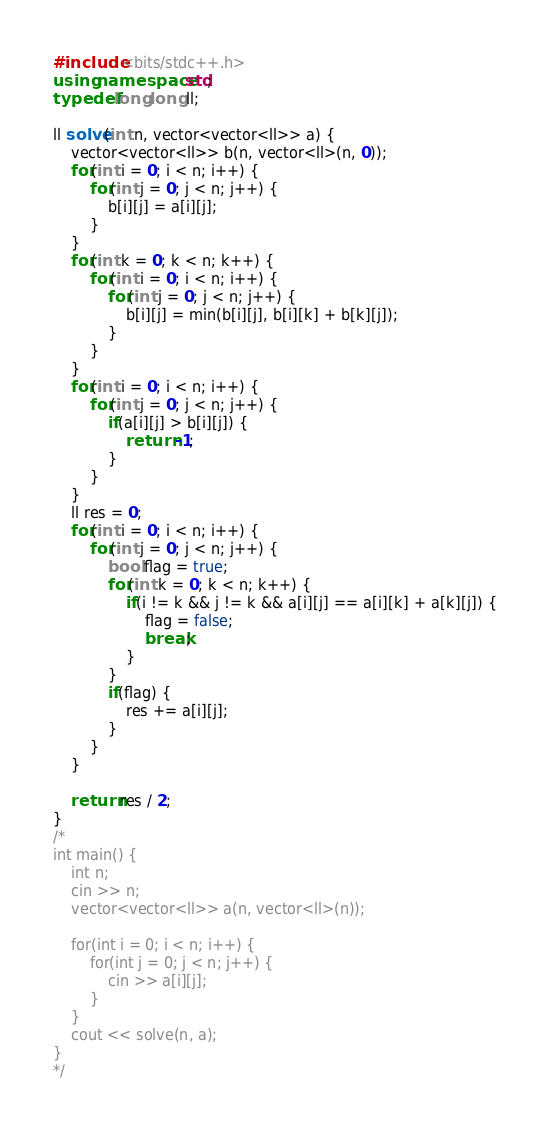Convert code to text. <code><loc_0><loc_0><loc_500><loc_500><_C++_>#include <bits/stdc++.h>
using namespace std;
typedef long long ll;

ll solve(int n, vector<vector<ll>> a) {
    vector<vector<ll>> b(n, vector<ll>(n, 0));
    for(int i = 0; i < n; i++) {
        for(int j = 0; j < n; j++) {
            b[i][j] = a[i][j];
        }
    }
    for(int k = 0; k < n; k++) {
        for(int i = 0; i < n; i++) {
            for(int j = 0; j < n; j++) {
                b[i][j] = min(b[i][j], b[i][k] + b[k][j]);
            }
        }
    }
    for(int i = 0; i < n; i++) {
        for(int j = 0; j < n; j++) {
            if(a[i][j] > b[i][j]) {
                return -1;
            }
        }
    }
    ll res = 0;
    for(int i = 0; i < n; i++) {
        for(int j = 0; j < n; j++) {
            bool flag = true;
            for(int k = 0; k < n; k++) {
                if(i != k && j != k && a[i][j] == a[i][k] + a[k][j]) {
                    flag = false;
                    break;
                }
            }
            if(flag) {
                res += a[i][j];
            }
        }
    }

    return res / 2;
}
/*
int main() {
    int n;
    cin >> n;
    vector<vector<ll>> a(n, vector<ll>(n));

    for(int i = 0; i < n; i++) {
        for(int j = 0; j < n; j++) {
            cin >> a[i][j];
        }
    }
    cout << solve(n, a);
}
*/</code> 